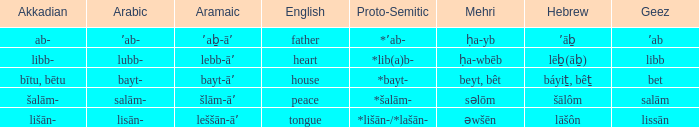If the proto-semitic is *bayt-, what are the geez? Bet. 